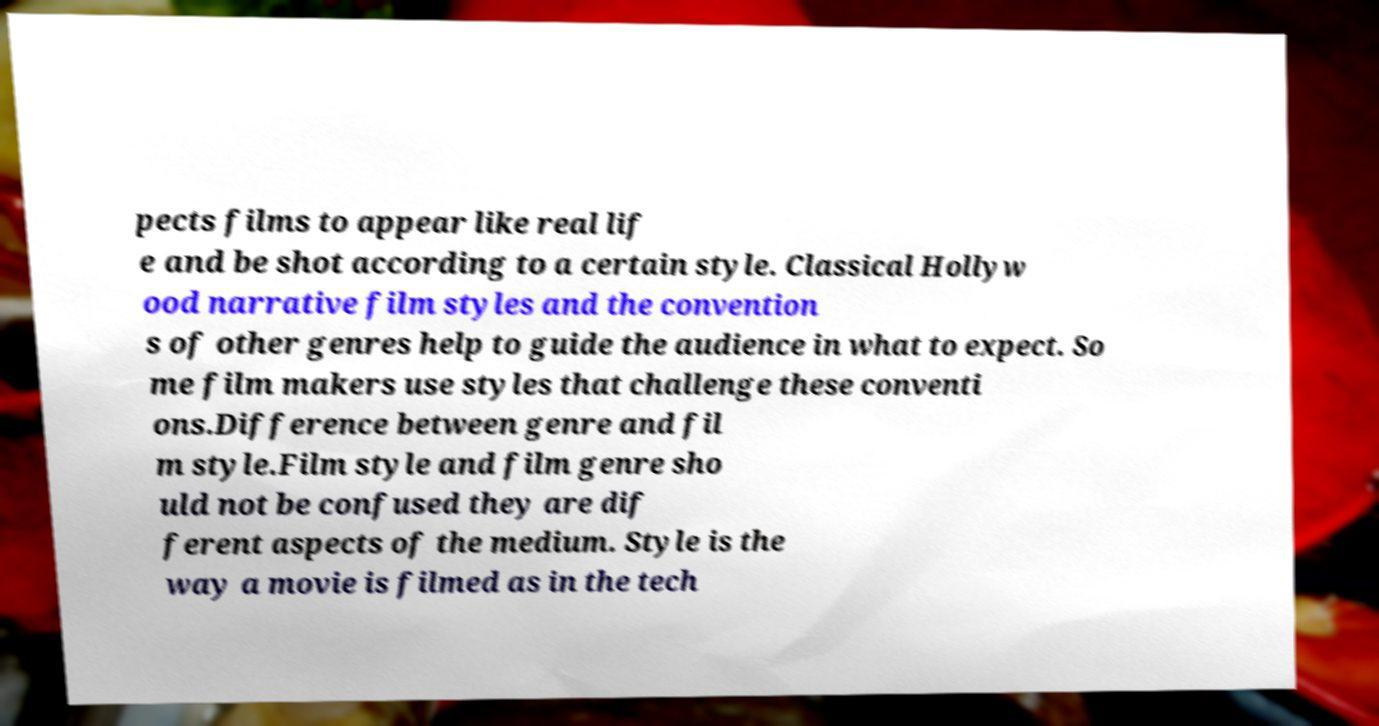I need the written content from this picture converted into text. Can you do that? pects films to appear like real lif e and be shot according to a certain style. Classical Hollyw ood narrative film styles and the convention s of other genres help to guide the audience in what to expect. So me film makers use styles that challenge these conventi ons.Difference between genre and fil m style.Film style and film genre sho uld not be confused they are dif ferent aspects of the medium. Style is the way a movie is filmed as in the tech 